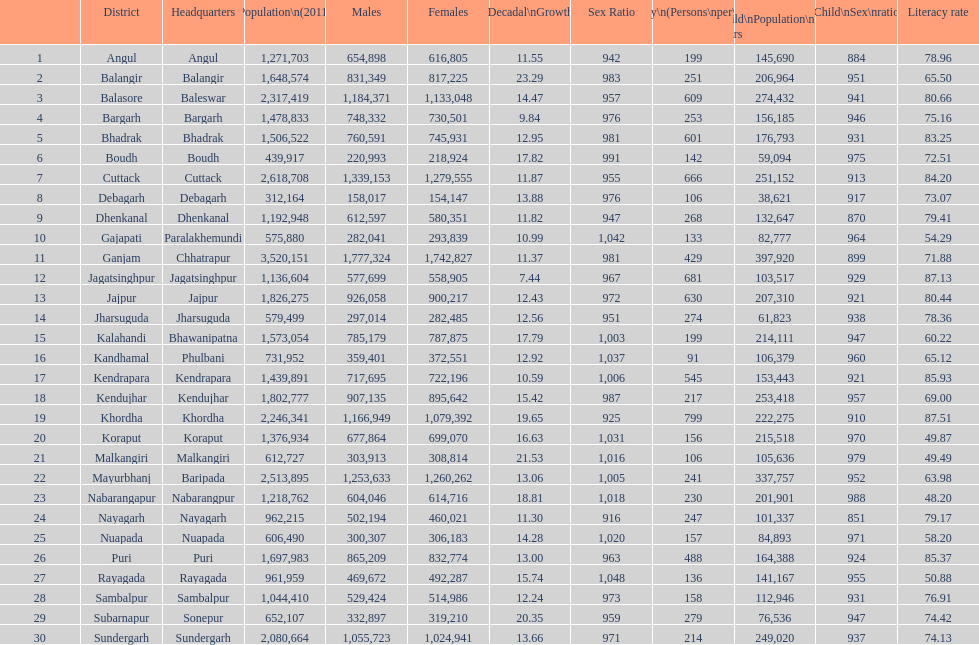What is the number of districts with percentage decadal growth above 15% 10. 